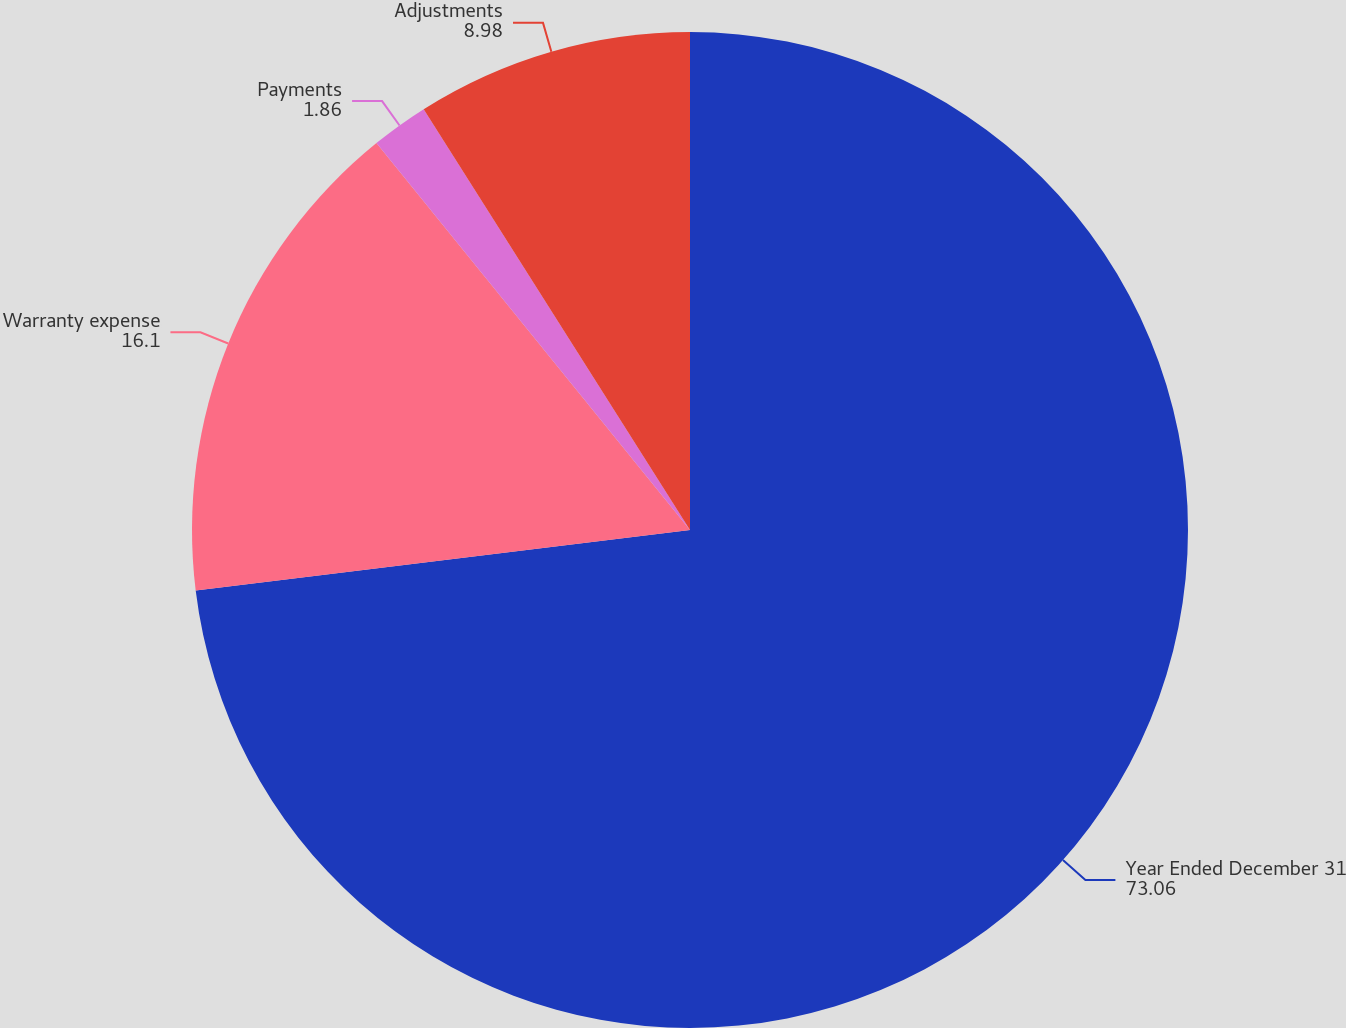Convert chart. <chart><loc_0><loc_0><loc_500><loc_500><pie_chart><fcel>Year Ended December 31<fcel>Warranty expense<fcel>Payments<fcel>Adjustments<nl><fcel>73.06%<fcel>16.1%<fcel>1.86%<fcel>8.98%<nl></chart> 